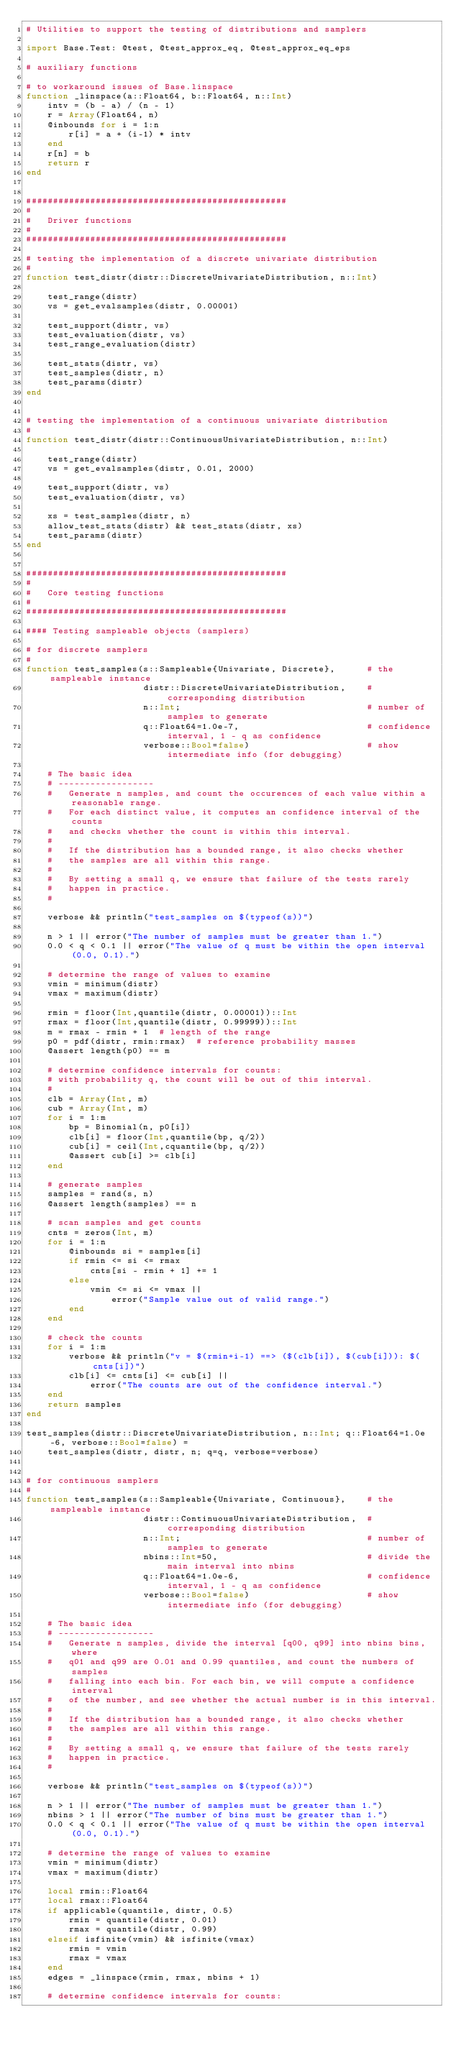<code> <loc_0><loc_0><loc_500><loc_500><_Julia_># Utilities to support the testing of distributions and samplers

import Base.Test: @test, @test_approx_eq, @test_approx_eq_eps

# auxiliary functions

# to workaround issues of Base.linspace
function _linspace(a::Float64, b::Float64, n::Int)
    intv = (b - a) / (n - 1)
    r = Array(Float64, n)
    @inbounds for i = 1:n
        r[i] = a + (i-1) * intv
    end
    r[n] = b
    return r
end


#################################################
#
#   Driver functions
#
#################################################

# testing the implementation of a discrete univariate distribution
#
function test_distr(distr::DiscreteUnivariateDistribution, n::Int)

    test_range(distr)
    vs = get_evalsamples(distr, 0.00001)

    test_support(distr, vs)
    test_evaluation(distr, vs)
    test_range_evaluation(distr)

    test_stats(distr, vs)
    test_samples(distr, n)
    test_params(distr)
end


# testing the implementation of a continuous univariate distribution
#
function test_distr(distr::ContinuousUnivariateDistribution, n::Int)

    test_range(distr)
    vs = get_evalsamples(distr, 0.01, 2000)

    test_support(distr, vs)
    test_evaluation(distr, vs)

    xs = test_samples(distr, n)
    allow_test_stats(distr) && test_stats(distr, xs)
    test_params(distr)
end


#################################################
#
#   Core testing functions
#
#################################################

#### Testing sampleable objects (samplers)

# for discrete samplers
#
function test_samples(s::Sampleable{Univariate, Discrete},      # the sampleable instance
                      distr::DiscreteUnivariateDistribution,    # corresponding distribution
                      n::Int;                                   # number of samples to generate
                      q::Float64=1.0e-7,                        # confidence interval, 1 - q as confidence
                      verbose::Bool=false)                      # show intermediate info (for debugging)

    # The basic idea
    # ------------------
    #   Generate n samples, and count the occurences of each value within a reasonable range.
    #   For each distinct value, it computes an confidence interval of the counts
    #   and checks whether the count is within this interval.
    #
    #   If the distribution has a bounded range, it also checks whether
    #   the samples are all within this range.
    #
    #   By setting a small q, we ensure that failure of the tests rarely
    #   happen in practice.
    #

    verbose && println("test_samples on $(typeof(s))")

    n > 1 || error("The number of samples must be greater than 1.")
    0.0 < q < 0.1 || error("The value of q must be within the open interval (0.0, 0.1).")

    # determine the range of values to examine
    vmin = minimum(distr)
    vmax = maximum(distr)

    rmin = floor(Int,quantile(distr, 0.00001))::Int
    rmax = floor(Int,quantile(distr, 0.99999))::Int
    m = rmax - rmin + 1  # length of the range
    p0 = pdf(distr, rmin:rmax)  # reference probability masses
    @assert length(p0) == m

    # determine confidence intervals for counts:
    # with probability q, the count will be out of this interval.
    #
    clb = Array(Int, m)
    cub = Array(Int, m)
    for i = 1:m
        bp = Binomial(n, p0[i])
        clb[i] = floor(Int,quantile(bp, q/2))
        cub[i] = ceil(Int,cquantile(bp, q/2))
        @assert cub[i] >= clb[i]
    end

    # generate samples
    samples = rand(s, n)
    @assert length(samples) == n

    # scan samples and get counts
    cnts = zeros(Int, m)
    for i = 1:n
        @inbounds si = samples[i]
        if rmin <= si <= rmax
            cnts[si - rmin + 1] += 1
        else
            vmin <= si <= vmax ||
                error("Sample value out of valid range.")
        end
    end

    # check the counts
    for i = 1:m
        verbose && println("v = $(rmin+i-1) ==> ($(clb[i]), $(cub[i])): $(cnts[i])")
        clb[i] <= cnts[i] <= cub[i] ||
            error("The counts are out of the confidence interval.")
    end
    return samples
end

test_samples(distr::DiscreteUnivariateDistribution, n::Int; q::Float64=1.0e-6, verbose::Bool=false) =
    test_samples(distr, distr, n; q=q, verbose=verbose)


# for continuous samplers
#
function test_samples(s::Sampleable{Univariate, Continuous},    # the sampleable instance
                      distr::ContinuousUnivariateDistribution,  # corresponding distribution
                      n::Int;                                   # number of samples to generate
                      nbins::Int=50,                            # divide the main interval into nbins
                      q::Float64=1.0e-6,                        # confidence interval, 1 - q as confidence
                      verbose::Bool=false)                      # show intermediate info (for debugging)

    # The basic idea
    # ------------------
    #   Generate n samples, divide the interval [q00, q99] into nbins bins, where
    #   q01 and q99 are 0.01 and 0.99 quantiles, and count the numbers of samples
    #   falling into each bin. For each bin, we will compute a confidence interval
    #   of the number, and see whether the actual number is in this interval.
    #
    #   If the distribution has a bounded range, it also checks whether
    #   the samples are all within this range.
    #
    #   By setting a small q, we ensure that failure of the tests rarely
    #   happen in practice.
    #

    verbose && println("test_samples on $(typeof(s))")

    n > 1 || error("The number of samples must be greater than 1.")
    nbins > 1 || error("The number of bins must be greater than 1.")
    0.0 < q < 0.1 || error("The value of q must be within the open interval (0.0, 0.1).")

    # determine the range of values to examine
    vmin = minimum(distr)
    vmax = maximum(distr)

    local rmin::Float64
    local rmax::Float64
    if applicable(quantile, distr, 0.5)
        rmin = quantile(distr, 0.01)
        rmax = quantile(distr, 0.99)
    elseif isfinite(vmin) && isfinite(vmax)
        rmin = vmin
        rmax = vmax
    end
    edges = _linspace(rmin, rmax, nbins + 1)

    # determine confidence intervals for counts:</code> 